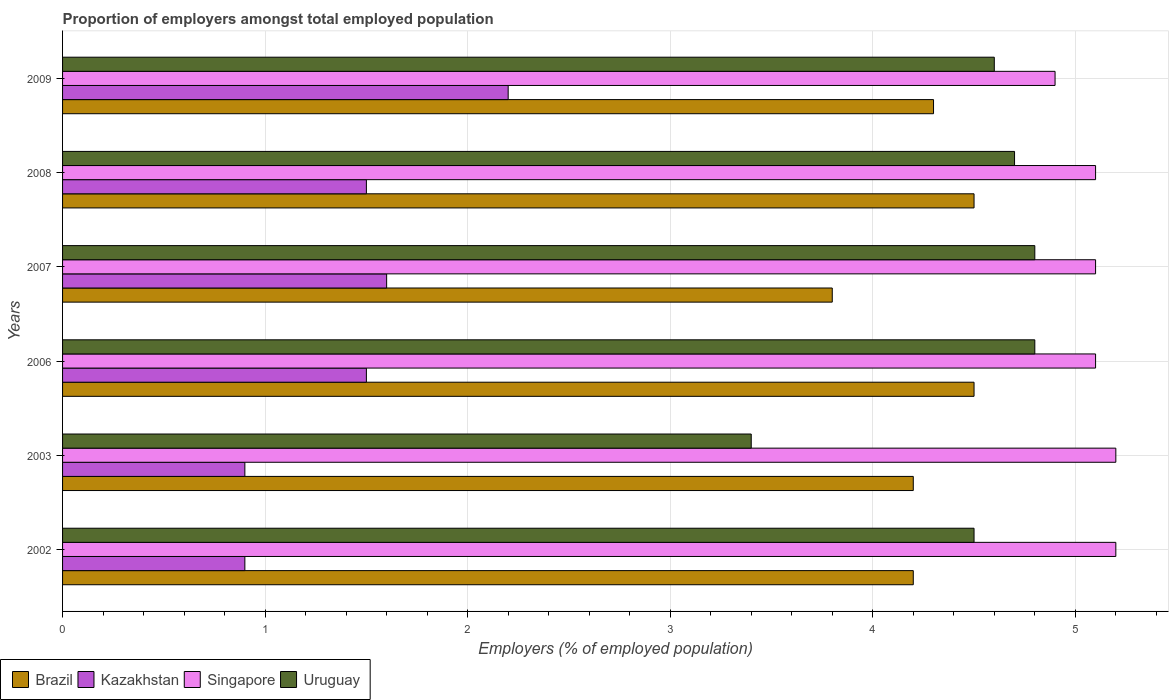How many different coloured bars are there?
Provide a short and direct response. 4. Are the number of bars per tick equal to the number of legend labels?
Your response must be concise. Yes. What is the label of the 5th group of bars from the top?
Keep it short and to the point. 2003. In how many cases, is the number of bars for a given year not equal to the number of legend labels?
Your answer should be very brief. 0. What is the proportion of employers in Uruguay in 2008?
Keep it short and to the point. 4.7. Across all years, what is the maximum proportion of employers in Kazakhstan?
Offer a very short reply. 2.2. Across all years, what is the minimum proportion of employers in Uruguay?
Your answer should be very brief. 3.4. What is the total proportion of employers in Kazakhstan in the graph?
Your answer should be very brief. 8.6. What is the difference between the proportion of employers in Kazakhstan in 2006 and that in 2009?
Offer a very short reply. -0.7. What is the difference between the proportion of employers in Kazakhstan in 2007 and the proportion of employers in Uruguay in 2002?
Your response must be concise. -2.9. What is the average proportion of employers in Uruguay per year?
Give a very brief answer. 4.47. In the year 2007, what is the difference between the proportion of employers in Uruguay and proportion of employers in Kazakhstan?
Make the answer very short. 3.2. Is the difference between the proportion of employers in Uruguay in 2002 and 2006 greater than the difference between the proportion of employers in Kazakhstan in 2002 and 2006?
Provide a short and direct response. Yes. What is the difference between the highest and the lowest proportion of employers in Singapore?
Offer a very short reply. 0.3. Is the sum of the proportion of employers in Kazakhstan in 2003 and 2009 greater than the maximum proportion of employers in Brazil across all years?
Offer a very short reply. No. Is it the case that in every year, the sum of the proportion of employers in Kazakhstan and proportion of employers in Singapore is greater than the sum of proportion of employers in Uruguay and proportion of employers in Brazil?
Give a very brief answer. Yes. What does the 1st bar from the top in 2007 represents?
Ensure brevity in your answer.  Uruguay. What does the 4th bar from the bottom in 2006 represents?
Your answer should be very brief. Uruguay. Are the values on the major ticks of X-axis written in scientific E-notation?
Offer a terse response. No. How many legend labels are there?
Give a very brief answer. 4. What is the title of the graph?
Provide a succinct answer. Proportion of employers amongst total employed population. Does "Central African Republic" appear as one of the legend labels in the graph?
Your answer should be compact. No. What is the label or title of the X-axis?
Your response must be concise. Employers (% of employed population). What is the Employers (% of employed population) of Brazil in 2002?
Your answer should be very brief. 4.2. What is the Employers (% of employed population) of Kazakhstan in 2002?
Offer a terse response. 0.9. What is the Employers (% of employed population) of Singapore in 2002?
Offer a terse response. 5.2. What is the Employers (% of employed population) in Uruguay in 2002?
Offer a terse response. 4.5. What is the Employers (% of employed population) in Brazil in 2003?
Keep it short and to the point. 4.2. What is the Employers (% of employed population) of Kazakhstan in 2003?
Keep it short and to the point. 0.9. What is the Employers (% of employed population) of Singapore in 2003?
Your answer should be compact. 5.2. What is the Employers (% of employed population) in Uruguay in 2003?
Provide a short and direct response. 3.4. What is the Employers (% of employed population) of Brazil in 2006?
Provide a short and direct response. 4.5. What is the Employers (% of employed population) of Kazakhstan in 2006?
Provide a short and direct response. 1.5. What is the Employers (% of employed population) of Singapore in 2006?
Keep it short and to the point. 5.1. What is the Employers (% of employed population) in Uruguay in 2006?
Your answer should be compact. 4.8. What is the Employers (% of employed population) of Brazil in 2007?
Offer a terse response. 3.8. What is the Employers (% of employed population) of Kazakhstan in 2007?
Offer a very short reply. 1.6. What is the Employers (% of employed population) of Singapore in 2007?
Ensure brevity in your answer.  5.1. What is the Employers (% of employed population) of Uruguay in 2007?
Provide a succinct answer. 4.8. What is the Employers (% of employed population) in Singapore in 2008?
Offer a very short reply. 5.1. What is the Employers (% of employed population) in Uruguay in 2008?
Keep it short and to the point. 4.7. What is the Employers (% of employed population) in Brazil in 2009?
Your answer should be compact. 4.3. What is the Employers (% of employed population) in Kazakhstan in 2009?
Your answer should be compact. 2.2. What is the Employers (% of employed population) of Singapore in 2009?
Your answer should be compact. 4.9. What is the Employers (% of employed population) in Uruguay in 2009?
Give a very brief answer. 4.6. Across all years, what is the maximum Employers (% of employed population) in Brazil?
Your answer should be very brief. 4.5. Across all years, what is the maximum Employers (% of employed population) of Kazakhstan?
Your response must be concise. 2.2. Across all years, what is the maximum Employers (% of employed population) of Singapore?
Your response must be concise. 5.2. Across all years, what is the maximum Employers (% of employed population) of Uruguay?
Keep it short and to the point. 4.8. Across all years, what is the minimum Employers (% of employed population) of Brazil?
Your response must be concise. 3.8. Across all years, what is the minimum Employers (% of employed population) of Kazakhstan?
Ensure brevity in your answer.  0.9. Across all years, what is the minimum Employers (% of employed population) of Singapore?
Your answer should be very brief. 4.9. Across all years, what is the minimum Employers (% of employed population) of Uruguay?
Your answer should be compact. 3.4. What is the total Employers (% of employed population) in Kazakhstan in the graph?
Provide a short and direct response. 8.6. What is the total Employers (% of employed population) in Singapore in the graph?
Your answer should be compact. 30.6. What is the total Employers (% of employed population) of Uruguay in the graph?
Give a very brief answer. 26.8. What is the difference between the Employers (% of employed population) of Brazil in 2002 and that in 2003?
Your response must be concise. 0. What is the difference between the Employers (% of employed population) in Kazakhstan in 2002 and that in 2006?
Offer a very short reply. -0.6. What is the difference between the Employers (% of employed population) of Uruguay in 2002 and that in 2006?
Offer a terse response. -0.3. What is the difference between the Employers (% of employed population) of Uruguay in 2002 and that in 2008?
Your response must be concise. -0.2. What is the difference between the Employers (% of employed population) of Singapore in 2002 and that in 2009?
Offer a terse response. 0.3. What is the difference between the Employers (% of employed population) in Brazil in 2003 and that in 2006?
Provide a succinct answer. -0.3. What is the difference between the Employers (% of employed population) of Kazakhstan in 2003 and that in 2006?
Offer a terse response. -0.6. What is the difference between the Employers (% of employed population) of Singapore in 2003 and that in 2006?
Make the answer very short. 0.1. What is the difference between the Employers (% of employed population) of Uruguay in 2003 and that in 2006?
Ensure brevity in your answer.  -1.4. What is the difference between the Employers (% of employed population) in Kazakhstan in 2003 and that in 2007?
Ensure brevity in your answer.  -0.7. What is the difference between the Employers (% of employed population) of Singapore in 2003 and that in 2007?
Keep it short and to the point. 0.1. What is the difference between the Employers (% of employed population) of Uruguay in 2003 and that in 2007?
Provide a succinct answer. -1.4. What is the difference between the Employers (% of employed population) in Uruguay in 2003 and that in 2008?
Ensure brevity in your answer.  -1.3. What is the difference between the Employers (% of employed population) in Kazakhstan in 2003 and that in 2009?
Your answer should be compact. -1.3. What is the difference between the Employers (% of employed population) in Singapore in 2003 and that in 2009?
Offer a terse response. 0.3. What is the difference between the Employers (% of employed population) of Uruguay in 2003 and that in 2009?
Provide a short and direct response. -1.2. What is the difference between the Employers (% of employed population) of Singapore in 2006 and that in 2007?
Give a very brief answer. 0. What is the difference between the Employers (% of employed population) of Uruguay in 2006 and that in 2007?
Offer a terse response. 0. What is the difference between the Employers (% of employed population) in Brazil in 2006 and that in 2008?
Keep it short and to the point. 0. What is the difference between the Employers (% of employed population) of Uruguay in 2006 and that in 2008?
Your response must be concise. 0.1. What is the difference between the Employers (% of employed population) in Uruguay in 2006 and that in 2009?
Provide a succinct answer. 0.2. What is the difference between the Employers (% of employed population) of Brazil in 2007 and that in 2008?
Keep it short and to the point. -0.7. What is the difference between the Employers (% of employed population) of Brazil in 2007 and that in 2009?
Offer a terse response. -0.5. What is the difference between the Employers (% of employed population) of Kazakhstan in 2007 and that in 2009?
Offer a terse response. -0.6. What is the difference between the Employers (% of employed population) in Uruguay in 2007 and that in 2009?
Your response must be concise. 0.2. What is the difference between the Employers (% of employed population) of Kazakhstan in 2008 and that in 2009?
Provide a short and direct response. -0.7. What is the difference between the Employers (% of employed population) in Kazakhstan in 2002 and the Employers (% of employed population) in Singapore in 2003?
Make the answer very short. -4.3. What is the difference between the Employers (% of employed population) of Kazakhstan in 2002 and the Employers (% of employed population) of Uruguay in 2003?
Ensure brevity in your answer.  -2.5. What is the difference between the Employers (% of employed population) of Singapore in 2002 and the Employers (% of employed population) of Uruguay in 2003?
Keep it short and to the point. 1.8. What is the difference between the Employers (% of employed population) of Brazil in 2002 and the Employers (% of employed population) of Singapore in 2006?
Your answer should be compact. -0.9. What is the difference between the Employers (% of employed population) of Brazil in 2002 and the Employers (% of employed population) of Kazakhstan in 2007?
Give a very brief answer. 2.6. What is the difference between the Employers (% of employed population) of Brazil in 2002 and the Employers (% of employed population) of Uruguay in 2007?
Provide a succinct answer. -0.6. What is the difference between the Employers (% of employed population) of Kazakhstan in 2002 and the Employers (% of employed population) of Singapore in 2007?
Make the answer very short. -4.2. What is the difference between the Employers (% of employed population) of Brazil in 2002 and the Employers (% of employed population) of Kazakhstan in 2008?
Keep it short and to the point. 2.7. What is the difference between the Employers (% of employed population) in Brazil in 2002 and the Employers (% of employed population) in Uruguay in 2008?
Make the answer very short. -0.5. What is the difference between the Employers (% of employed population) of Kazakhstan in 2002 and the Employers (% of employed population) of Singapore in 2008?
Keep it short and to the point. -4.2. What is the difference between the Employers (% of employed population) of Kazakhstan in 2002 and the Employers (% of employed population) of Uruguay in 2008?
Make the answer very short. -3.8. What is the difference between the Employers (% of employed population) in Brazil in 2002 and the Employers (% of employed population) in Kazakhstan in 2009?
Ensure brevity in your answer.  2. What is the difference between the Employers (% of employed population) in Kazakhstan in 2002 and the Employers (% of employed population) in Singapore in 2009?
Provide a short and direct response. -4. What is the difference between the Employers (% of employed population) in Brazil in 2003 and the Employers (% of employed population) in Kazakhstan in 2006?
Your response must be concise. 2.7. What is the difference between the Employers (% of employed population) of Brazil in 2003 and the Employers (% of employed population) of Uruguay in 2006?
Make the answer very short. -0.6. What is the difference between the Employers (% of employed population) in Kazakhstan in 2003 and the Employers (% of employed population) in Singapore in 2006?
Offer a terse response. -4.2. What is the difference between the Employers (% of employed population) in Singapore in 2003 and the Employers (% of employed population) in Uruguay in 2006?
Ensure brevity in your answer.  0.4. What is the difference between the Employers (% of employed population) of Brazil in 2003 and the Employers (% of employed population) of Singapore in 2007?
Make the answer very short. -0.9. What is the difference between the Employers (% of employed population) in Brazil in 2003 and the Employers (% of employed population) in Uruguay in 2007?
Give a very brief answer. -0.6. What is the difference between the Employers (% of employed population) in Kazakhstan in 2003 and the Employers (% of employed population) in Singapore in 2007?
Your response must be concise. -4.2. What is the difference between the Employers (% of employed population) of Singapore in 2003 and the Employers (% of employed population) of Uruguay in 2007?
Offer a terse response. 0.4. What is the difference between the Employers (% of employed population) of Brazil in 2003 and the Employers (% of employed population) of Kazakhstan in 2008?
Your response must be concise. 2.7. What is the difference between the Employers (% of employed population) of Kazakhstan in 2003 and the Employers (% of employed population) of Singapore in 2008?
Give a very brief answer. -4.2. What is the difference between the Employers (% of employed population) of Brazil in 2003 and the Employers (% of employed population) of Kazakhstan in 2009?
Offer a terse response. 2. What is the difference between the Employers (% of employed population) in Kazakhstan in 2003 and the Employers (% of employed population) in Uruguay in 2009?
Offer a terse response. -3.7. What is the difference between the Employers (% of employed population) in Singapore in 2003 and the Employers (% of employed population) in Uruguay in 2009?
Your response must be concise. 0.6. What is the difference between the Employers (% of employed population) in Brazil in 2006 and the Employers (% of employed population) in Kazakhstan in 2007?
Ensure brevity in your answer.  2.9. What is the difference between the Employers (% of employed population) in Brazil in 2006 and the Employers (% of employed population) in Singapore in 2007?
Provide a succinct answer. -0.6. What is the difference between the Employers (% of employed population) in Brazil in 2006 and the Employers (% of employed population) in Uruguay in 2007?
Your response must be concise. -0.3. What is the difference between the Employers (% of employed population) of Kazakhstan in 2006 and the Employers (% of employed population) of Singapore in 2007?
Your answer should be very brief. -3.6. What is the difference between the Employers (% of employed population) in Kazakhstan in 2006 and the Employers (% of employed population) in Uruguay in 2007?
Make the answer very short. -3.3. What is the difference between the Employers (% of employed population) in Brazil in 2006 and the Employers (% of employed population) in Singapore in 2008?
Offer a very short reply. -0.6. What is the difference between the Employers (% of employed population) in Brazil in 2006 and the Employers (% of employed population) in Uruguay in 2008?
Provide a short and direct response. -0.2. What is the difference between the Employers (% of employed population) of Kazakhstan in 2006 and the Employers (% of employed population) of Uruguay in 2009?
Your answer should be very brief. -3.1. What is the difference between the Employers (% of employed population) in Singapore in 2006 and the Employers (% of employed population) in Uruguay in 2009?
Offer a very short reply. 0.5. What is the difference between the Employers (% of employed population) in Brazil in 2007 and the Employers (% of employed population) in Kazakhstan in 2008?
Make the answer very short. 2.3. What is the difference between the Employers (% of employed population) of Kazakhstan in 2007 and the Employers (% of employed population) of Singapore in 2008?
Ensure brevity in your answer.  -3.5. What is the difference between the Employers (% of employed population) in Kazakhstan in 2007 and the Employers (% of employed population) in Singapore in 2009?
Your response must be concise. -3.3. What is the difference between the Employers (% of employed population) of Singapore in 2007 and the Employers (% of employed population) of Uruguay in 2009?
Give a very brief answer. 0.5. What is the difference between the Employers (% of employed population) in Brazil in 2008 and the Employers (% of employed population) in Singapore in 2009?
Your response must be concise. -0.4. What is the difference between the Employers (% of employed population) in Kazakhstan in 2008 and the Employers (% of employed population) in Singapore in 2009?
Give a very brief answer. -3.4. What is the difference between the Employers (% of employed population) of Singapore in 2008 and the Employers (% of employed population) of Uruguay in 2009?
Offer a terse response. 0.5. What is the average Employers (% of employed population) in Brazil per year?
Give a very brief answer. 4.25. What is the average Employers (% of employed population) in Kazakhstan per year?
Your response must be concise. 1.43. What is the average Employers (% of employed population) of Uruguay per year?
Your response must be concise. 4.47. In the year 2002, what is the difference between the Employers (% of employed population) in Brazil and Employers (% of employed population) in Singapore?
Ensure brevity in your answer.  -1. In the year 2002, what is the difference between the Employers (% of employed population) in Brazil and Employers (% of employed population) in Uruguay?
Offer a terse response. -0.3. In the year 2002, what is the difference between the Employers (% of employed population) in Kazakhstan and Employers (% of employed population) in Singapore?
Provide a short and direct response. -4.3. In the year 2002, what is the difference between the Employers (% of employed population) in Kazakhstan and Employers (% of employed population) in Uruguay?
Make the answer very short. -3.6. In the year 2002, what is the difference between the Employers (% of employed population) in Singapore and Employers (% of employed population) in Uruguay?
Make the answer very short. 0.7. In the year 2003, what is the difference between the Employers (% of employed population) of Kazakhstan and Employers (% of employed population) of Singapore?
Provide a short and direct response. -4.3. In the year 2003, what is the difference between the Employers (% of employed population) in Kazakhstan and Employers (% of employed population) in Uruguay?
Keep it short and to the point. -2.5. In the year 2006, what is the difference between the Employers (% of employed population) in Brazil and Employers (% of employed population) in Kazakhstan?
Your response must be concise. 3. In the year 2006, what is the difference between the Employers (% of employed population) of Brazil and Employers (% of employed population) of Singapore?
Your response must be concise. -0.6. In the year 2006, what is the difference between the Employers (% of employed population) in Singapore and Employers (% of employed population) in Uruguay?
Offer a terse response. 0.3. In the year 2007, what is the difference between the Employers (% of employed population) in Brazil and Employers (% of employed population) in Singapore?
Keep it short and to the point. -1.3. In the year 2007, what is the difference between the Employers (% of employed population) of Brazil and Employers (% of employed population) of Uruguay?
Offer a very short reply. -1. In the year 2007, what is the difference between the Employers (% of employed population) in Kazakhstan and Employers (% of employed population) in Uruguay?
Ensure brevity in your answer.  -3.2. In the year 2007, what is the difference between the Employers (% of employed population) of Singapore and Employers (% of employed population) of Uruguay?
Your answer should be very brief. 0.3. In the year 2008, what is the difference between the Employers (% of employed population) of Brazil and Employers (% of employed population) of Kazakhstan?
Provide a succinct answer. 3. In the year 2008, what is the difference between the Employers (% of employed population) of Brazil and Employers (% of employed population) of Uruguay?
Offer a terse response. -0.2. In the year 2008, what is the difference between the Employers (% of employed population) of Singapore and Employers (% of employed population) of Uruguay?
Your answer should be very brief. 0.4. In the year 2009, what is the difference between the Employers (% of employed population) in Kazakhstan and Employers (% of employed population) in Uruguay?
Keep it short and to the point. -2.4. What is the ratio of the Employers (% of employed population) in Brazil in 2002 to that in 2003?
Your answer should be compact. 1. What is the ratio of the Employers (% of employed population) of Kazakhstan in 2002 to that in 2003?
Ensure brevity in your answer.  1. What is the ratio of the Employers (% of employed population) of Singapore in 2002 to that in 2003?
Provide a succinct answer. 1. What is the ratio of the Employers (% of employed population) in Uruguay in 2002 to that in 2003?
Give a very brief answer. 1.32. What is the ratio of the Employers (% of employed population) of Brazil in 2002 to that in 2006?
Ensure brevity in your answer.  0.93. What is the ratio of the Employers (% of employed population) in Singapore in 2002 to that in 2006?
Make the answer very short. 1.02. What is the ratio of the Employers (% of employed population) of Brazil in 2002 to that in 2007?
Offer a terse response. 1.11. What is the ratio of the Employers (% of employed population) in Kazakhstan in 2002 to that in 2007?
Your answer should be compact. 0.56. What is the ratio of the Employers (% of employed population) in Singapore in 2002 to that in 2007?
Provide a short and direct response. 1.02. What is the ratio of the Employers (% of employed population) in Kazakhstan in 2002 to that in 2008?
Offer a very short reply. 0.6. What is the ratio of the Employers (% of employed population) in Singapore in 2002 to that in 2008?
Your response must be concise. 1.02. What is the ratio of the Employers (% of employed population) of Uruguay in 2002 to that in 2008?
Give a very brief answer. 0.96. What is the ratio of the Employers (% of employed population) of Brazil in 2002 to that in 2009?
Ensure brevity in your answer.  0.98. What is the ratio of the Employers (% of employed population) of Kazakhstan in 2002 to that in 2009?
Your answer should be compact. 0.41. What is the ratio of the Employers (% of employed population) of Singapore in 2002 to that in 2009?
Make the answer very short. 1.06. What is the ratio of the Employers (% of employed population) of Uruguay in 2002 to that in 2009?
Keep it short and to the point. 0.98. What is the ratio of the Employers (% of employed population) of Singapore in 2003 to that in 2006?
Your answer should be compact. 1.02. What is the ratio of the Employers (% of employed population) of Uruguay in 2003 to that in 2006?
Ensure brevity in your answer.  0.71. What is the ratio of the Employers (% of employed population) in Brazil in 2003 to that in 2007?
Your answer should be very brief. 1.11. What is the ratio of the Employers (% of employed population) of Kazakhstan in 2003 to that in 2007?
Offer a very short reply. 0.56. What is the ratio of the Employers (% of employed population) in Singapore in 2003 to that in 2007?
Your answer should be compact. 1.02. What is the ratio of the Employers (% of employed population) of Uruguay in 2003 to that in 2007?
Make the answer very short. 0.71. What is the ratio of the Employers (% of employed population) in Brazil in 2003 to that in 2008?
Provide a succinct answer. 0.93. What is the ratio of the Employers (% of employed population) in Kazakhstan in 2003 to that in 2008?
Offer a terse response. 0.6. What is the ratio of the Employers (% of employed population) of Singapore in 2003 to that in 2008?
Offer a very short reply. 1.02. What is the ratio of the Employers (% of employed population) in Uruguay in 2003 to that in 2008?
Provide a succinct answer. 0.72. What is the ratio of the Employers (% of employed population) in Brazil in 2003 to that in 2009?
Provide a succinct answer. 0.98. What is the ratio of the Employers (% of employed population) of Kazakhstan in 2003 to that in 2009?
Keep it short and to the point. 0.41. What is the ratio of the Employers (% of employed population) in Singapore in 2003 to that in 2009?
Offer a very short reply. 1.06. What is the ratio of the Employers (% of employed population) in Uruguay in 2003 to that in 2009?
Your answer should be compact. 0.74. What is the ratio of the Employers (% of employed population) in Brazil in 2006 to that in 2007?
Offer a very short reply. 1.18. What is the ratio of the Employers (% of employed population) in Kazakhstan in 2006 to that in 2007?
Make the answer very short. 0.94. What is the ratio of the Employers (% of employed population) in Brazil in 2006 to that in 2008?
Keep it short and to the point. 1. What is the ratio of the Employers (% of employed population) of Singapore in 2006 to that in 2008?
Make the answer very short. 1. What is the ratio of the Employers (% of employed population) in Uruguay in 2006 to that in 2008?
Give a very brief answer. 1.02. What is the ratio of the Employers (% of employed population) in Brazil in 2006 to that in 2009?
Your response must be concise. 1.05. What is the ratio of the Employers (% of employed population) of Kazakhstan in 2006 to that in 2009?
Make the answer very short. 0.68. What is the ratio of the Employers (% of employed population) in Singapore in 2006 to that in 2009?
Make the answer very short. 1.04. What is the ratio of the Employers (% of employed population) of Uruguay in 2006 to that in 2009?
Provide a succinct answer. 1.04. What is the ratio of the Employers (% of employed population) in Brazil in 2007 to that in 2008?
Offer a very short reply. 0.84. What is the ratio of the Employers (% of employed population) in Kazakhstan in 2007 to that in 2008?
Ensure brevity in your answer.  1.07. What is the ratio of the Employers (% of employed population) in Uruguay in 2007 to that in 2008?
Your answer should be very brief. 1.02. What is the ratio of the Employers (% of employed population) of Brazil in 2007 to that in 2009?
Ensure brevity in your answer.  0.88. What is the ratio of the Employers (% of employed population) in Kazakhstan in 2007 to that in 2009?
Provide a succinct answer. 0.73. What is the ratio of the Employers (% of employed population) in Singapore in 2007 to that in 2009?
Your response must be concise. 1.04. What is the ratio of the Employers (% of employed population) of Uruguay in 2007 to that in 2009?
Offer a terse response. 1.04. What is the ratio of the Employers (% of employed population) of Brazil in 2008 to that in 2009?
Give a very brief answer. 1.05. What is the ratio of the Employers (% of employed population) of Kazakhstan in 2008 to that in 2009?
Keep it short and to the point. 0.68. What is the ratio of the Employers (% of employed population) in Singapore in 2008 to that in 2009?
Your response must be concise. 1.04. What is the ratio of the Employers (% of employed population) of Uruguay in 2008 to that in 2009?
Offer a terse response. 1.02. What is the difference between the highest and the second highest Employers (% of employed population) of Kazakhstan?
Keep it short and to the point. 0.6. What is the difference between the highest and the lowest Employers (% of employed population) of Brazil?
Give a very brief answer. 0.7. What is the difference between the highest and the lowest Employers (% of employed population) in Kazakhstan?
Provide a succinct answer. 1.3. 